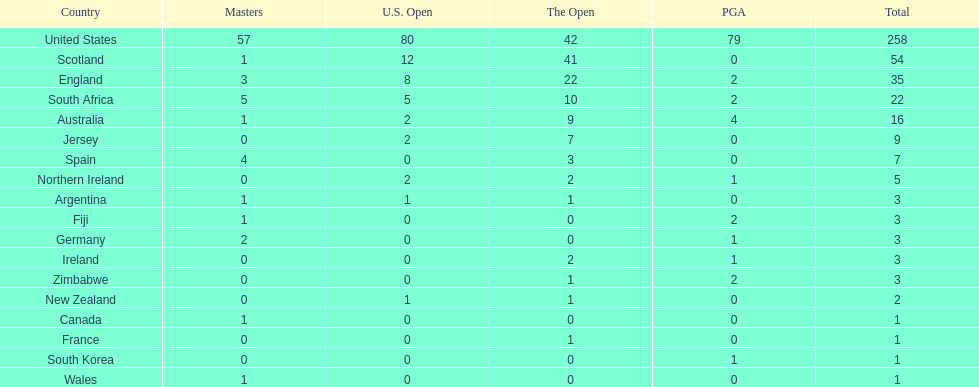Can you provide a list of every country? United States, Scotland, England, South Africa, Australia, Jersey, Spain, Northern Ireland, Argentina, Fiji, Germany, Ireland, Zimbabwe, New Zealand, Canada, France, South Korea, Wales. Which countries are situated in africa? South Africa, Zimbabwe. Out of those, which has the smallest number of accomplished golf players? Zimbabwe. 